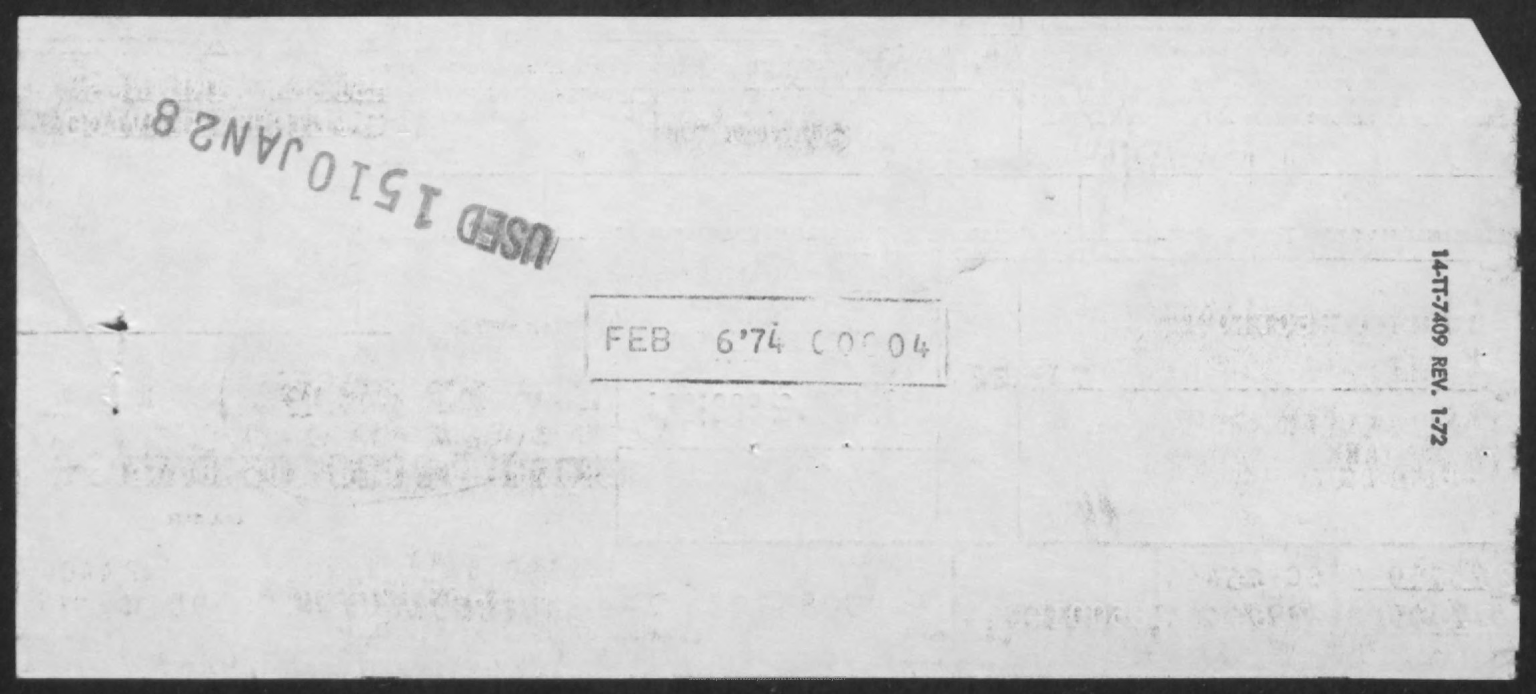Indicate a few pertinent items in this graphic. The rectangle shaped seal includes the month of February, which is visible. 